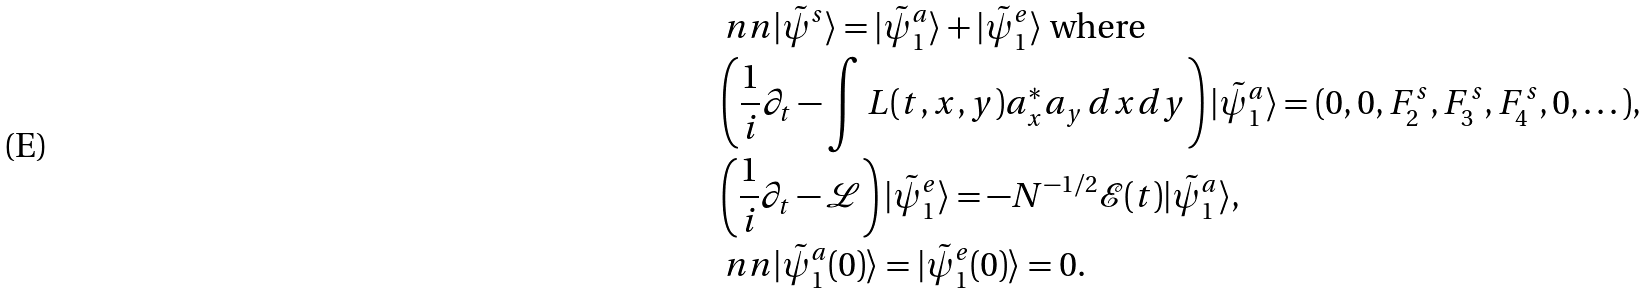<formula> <loc_0><loc_0><loc_500><loc_500>& \ n n | \tilde { \psi } ^ { s } \rangle = | \tilde { \psi } _ { 1 } ^ { a } \rangle + | \tilde { \psi } _ { 1 } ^ { e } \rangle \text { where } \\ & \left ( \frac { 1 } { i } \partial _ { t } - \int L ( t , x , y ) a _ { x } ^ { \ast } a _ { y } \, d x d y \right ) | \tilde { \psi } _ { 1 } ^ { a } \rangle = ( 0 , 0 , F _ { 2 } ^ { s } , F _ { 3 } ^ { s } , F _ { 4 } ^ { s } , 0 , \dots ) , \\ & \left ( \frac { 1 } { i } \partial _ { t } - \mathcal { L } \right ) | \tilde { \psi } _ { 1 } ^ { e } \rangle = - N ^ { - 1 / 2 } \mathcal { E } ( t ) | \tilde { \psi } _ { 1 } ^ { a } \rangle , \\ & \ n n | \tilde { \psi } _ { 1 } ^ { a } ( 0 ) \rangle = | \tilde { \psi } _ { 1 } ^ { e } ( 0 ) \rangle = 0 .</formula> 